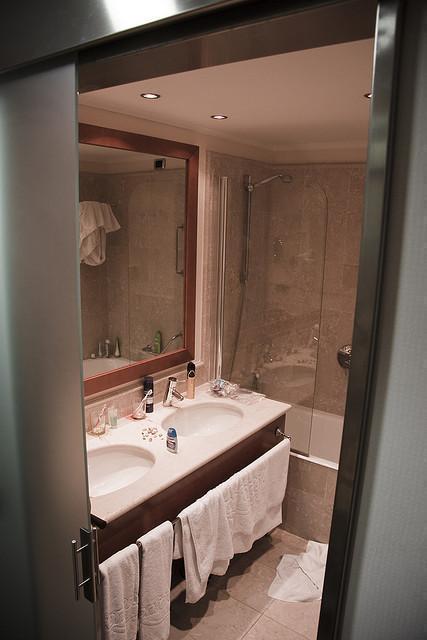How many people probably use this room?
Choose the correct response, then elucidate: 'Answer: answer
Rationale: rationale.'
Options: Five, four, two, three. Answer: two.
Rationale: The bathroom has two sinks in the vanity which is likley intended to be used by two people at once. 